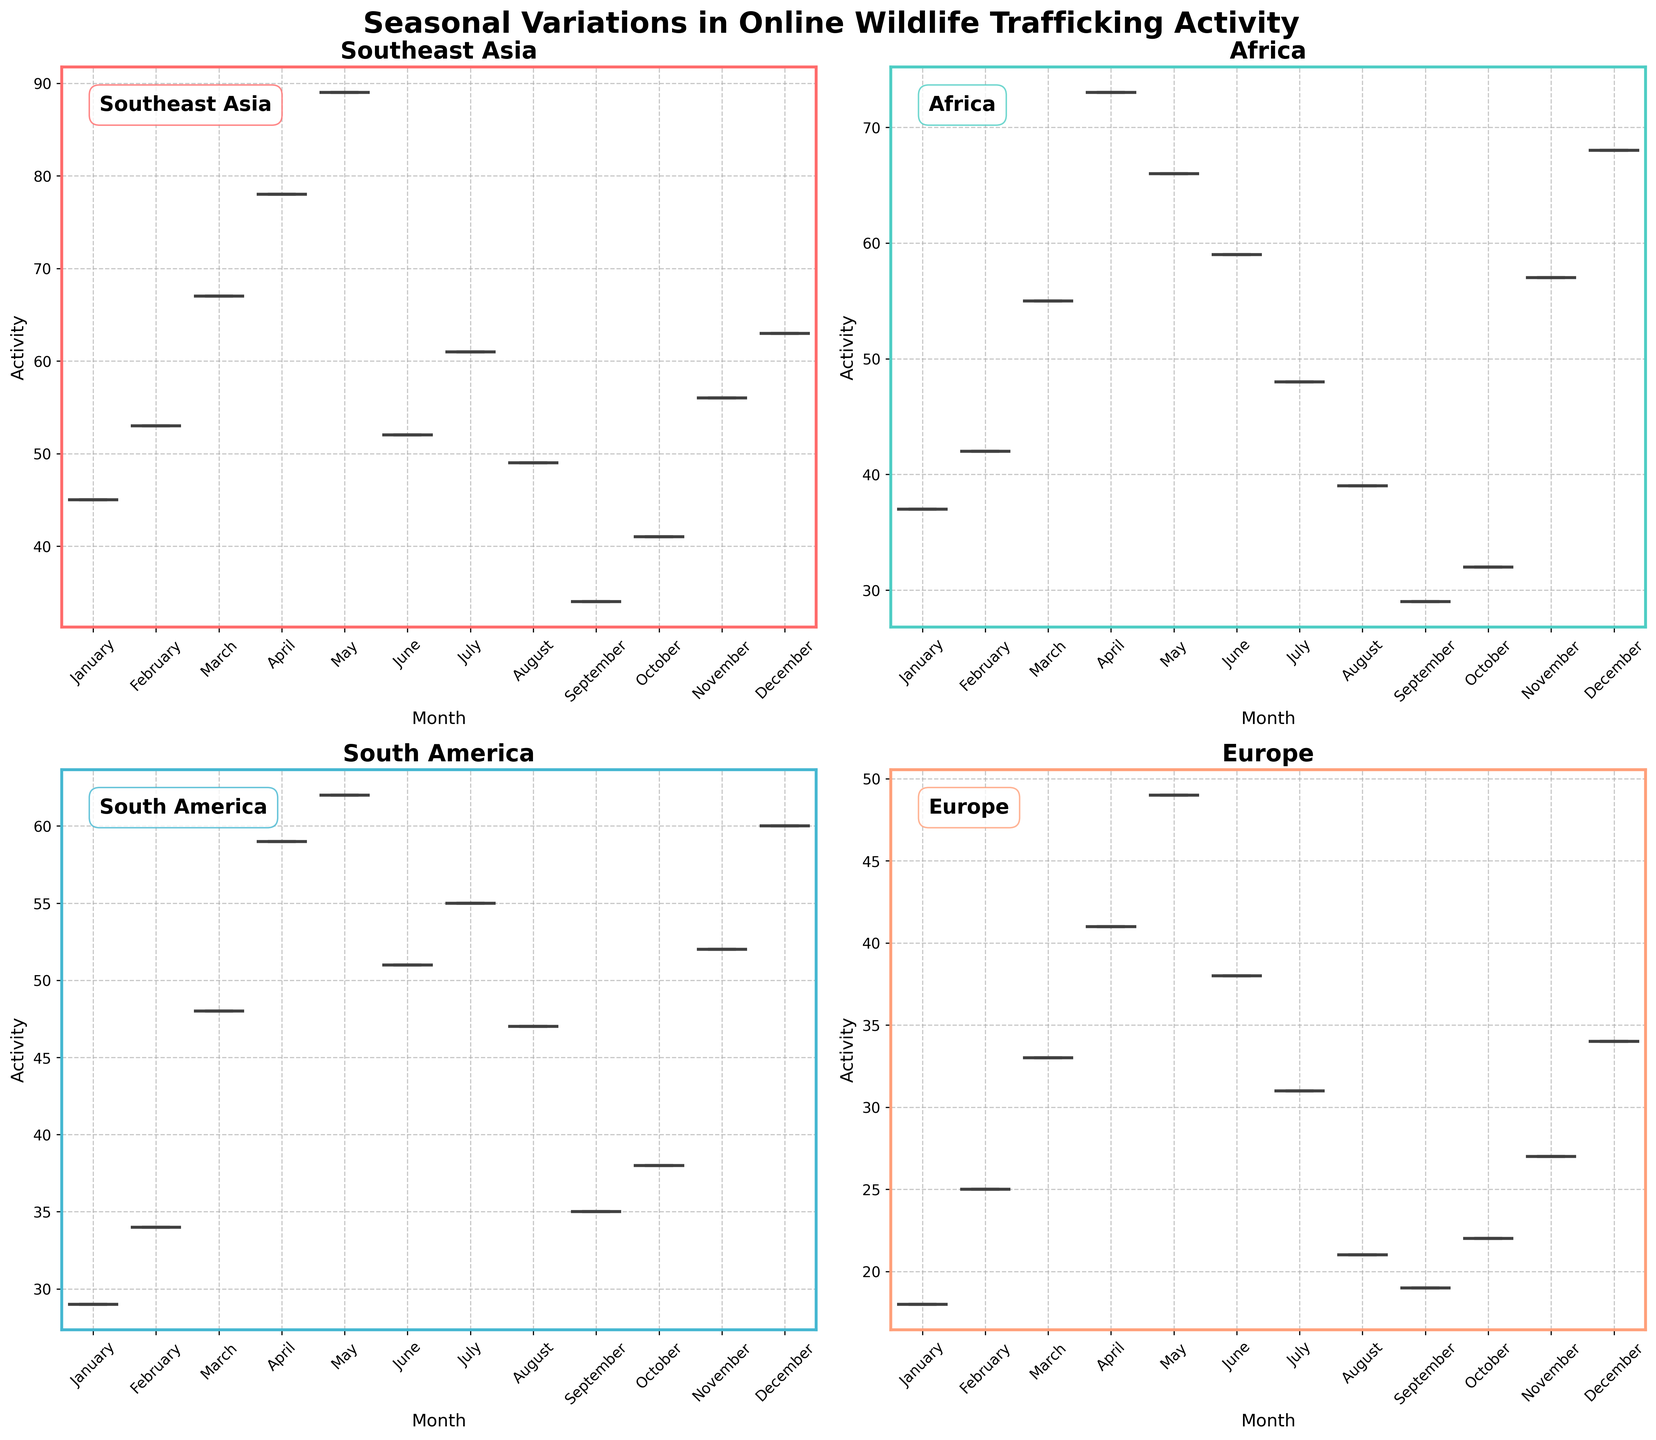Which region shows the highest activity in April? Looking at the box plots for April in each subplot, Southeast Asia shows the highest activity level compared to other regions.
Answer: Southeast Asia How does the activity in July compare between South America and Africa? Examining the median lines in the box plots for July in South America and Africa, the median activity is 55 for South America and 48 for Africa.
Answer: South America has higher activity Which months show the highest variability in wildlife trafficking activity in Southeast Asia? The months with the largest interquartile range (IQR) indicate higher variability. Observing the box plots, May and April have the widest boxes indicating higher variability.
Answer: May and April What is the median activity level in November for Europe? The median activity level is represented by the line inside the November box plot for Europe, which is approximately 27.
Answer: 27 Which region has the lowest median activity in December? By looking at the median lines of the December box plots across all regions, Europe has the lowest median activity.
Answer: Europe Are there any months without significant variation in activity for South America? Months with tighter boxes and shorter whiskers indicate less variation. In South America, June has tight boxes and whiskers, indicating low variation.
Answer: June How does the activity trend in Southeast Asia change throughout the first quarter (January to March)? The boxes and median lines for January, February, and March show an increasing trend in activity level.
Answer: Increasing What's the general activity trend in Africa comparing the first half to the second half of the year? Comparing January to June and July to December, Africa shows a decrease in activity from the first half to the second half of the year.
Answer: Decreasing In which month does South America show the least trafficking activity? The median line in the box plot for January indicates that it has the lowest activity level in South America.
Answer: January 